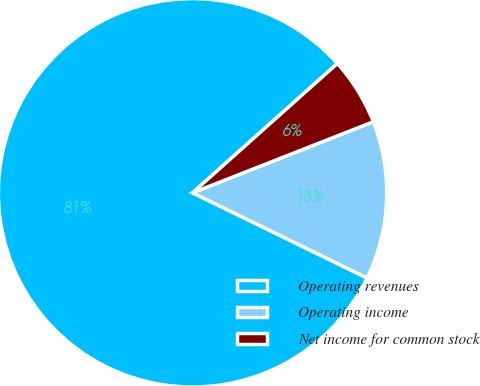Convert chart to OTSL. <chart><loc_0><loc_0><loc_500><loc_500><pie_chart><fcel>Operating revenues<fcel>Operating income<fcel>Net income for common stock<nl><fcel>81.17%<fcel>13.19%<fcel>5.64%<nl></chart> 